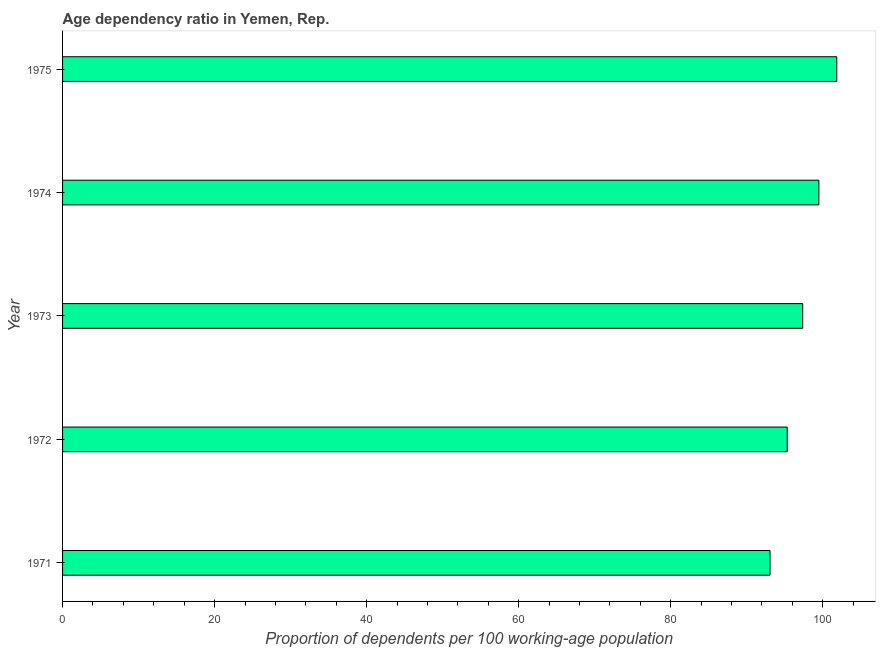What is the title of the graph?
Provide a succinct answer. Age dependency ratio in Yemen, Rep. What is the label or title of the X-axis?
Offer a very short reply. Proportion of dependents per 100 working-age population. What is the label or title of the Y-axis?
Offer a very short reply. Year. What is the age dependency ratio in 1975?
Your response must be concise. 101.85. Across all years, what is the maximum age dependency ratio?
Offer a very short reply. 101.85. Across all years, what is the minimum age dependency ratio?
Offer a terse response. 93.07. In which year was the age dependency ratio maximum?
Offer a very short reply. 1975. In which year was the age dependency ratio minimum?
Make the answer very short. 1971. What is the sum of the age dependency ratio?
Your answer should be very brief. 487.12. What is the average age dependency ratio per year?
Your answer should be very brief. 97.42. What is the median age dependency ratio?
Your answer should be compact. 97.37. Do a majority of the years between 1974 and 1973 (inclusive) have age dependency ratio greater than 20 ?
Provide a succinct answer. No. What is the ratio of the age dependency ratio in 1972 to that in 1974?
Make the answer very short. 0.96. Is the age dependency ratio in 1971 less than that in 1972?
Give a very brief answer. Yes. What is the difference between the highest and the second highest age dependency ratio?
Give a very brief answer. 2.35. What is the difference between the highest and the lowest age dependency ratio?
Your response must be concise. 8.78. In how many years, is the age dependency ratio greater than the average age dependency ratio taken over all years?
Offer a very short reply. 2. How many bars are there?
Provide a succinct answer. 5. Are all the bars in the graph horizontal?
Give a very brief answer. Yes. How many years are there in the graph?
Give a very brief answer. 5. What is the difference between two consecutive major ticks on the X-axis?
Ensure brevity in your answer.  20. Are the values on the major ticks of X-axis written in scientific E-notation?
Offer a terse response. No. What is the Proportion of dependents per 100 working-age population in 1971?
Offer a very short reply. 93.07. What is the Proportion of dependents per 100 working-age population of 1972?
Your answer should be very brief. 95.33. What is the Proportion of dependents per 100 working-age population in 1973?
Provide a succinct answer. 97.37. What is the Proportion of dependents per 100 working-age population of 1974?
Provide a short and direct response. 99.5. What is the Proportion of dependents per 100 working-age population in 1975?
Your answer should be very brief. 101.85. What is the difference between the Proportion of dependents per 100 working-age population in 1971 and 1972?
Provide a succinct answer. -2.26. What is the difference between the Proportion of dependents per 100 working-age population in 1971 and 1973?
Offer a very short reply. -4.3. What is the difference between the Proportion of dependents per 100 working-age population in 1971 and 1974?
Ensure brevity in your answer.  -6.43. What is the difference between the Proportion of dependents per 100 working-age population in 1971 and 1975?
Your response must be concise. -8.78. What is the difference between the Proportion of dependents per 100 working-age population in 1972 and 1973?
Your answer should be compact. -2.04. What is the difference between the Proportion of dependents per 100 working-age population in 1972 and 1974?
Your response must be concise. -4.16. What is the difference between the Proportion of dependents per 100 working-age population in 1972 and 1975?
Your response must be concise. -6.52. What is the difference between the Proportion of dependents per 100 working-age population in 1973 and 1974?
Keep it short and to the point. -2.13. What is the difference between the Proportion of dependents per 100 working-age population in 1973 and 1975?
Your response must be concise. -4.48. What is the difference between the Proportion of dependents per 100 working-age population in 1974 and 1975?
Keep it short and to the point. -2.36. What is the ratio of the Proportion of dependents per 100 working-age population in 1971 to that in 1973?
Give a very brief answer. 0.96. What is the ratio of the Proportion of dependents per 100 working-age population in 1971 to that in 1974?
Your response must be concise. 0.94. What is the ratio of the Proportion of dependents per 100 working-age population in 1971 to that in 1975?
Offer a very short reply. 0.91. What is the ratio of the Proportion of dependents per 100 working-age population in 1972 to that in 1973?
Your response must be concise. 0.98. What is the ratio of the Proportion of dependents per 100 working-age population in 1972 to that in 1974?
Ensure brevity in your answer.  0.96. What is the ratio of the Proportion of dependents per 100 working-age population in 1972 to that in 1975?
Provide a succinct answer. 0.94. What is the ratio of the Proportion of dependents per 100 working-age population in 1973 to that in 1974?
Provide a short and direct response. 0.98. What is the ratio of the Proportion of dependents per 100 working-age population in 1973 to that in 1975?
Your answer should be compact. 0.96. What is the ratio of the Proportion of dependents per 100 working-age population in 1974 to that in 1975?
Offer a very short reply. 0.98. 